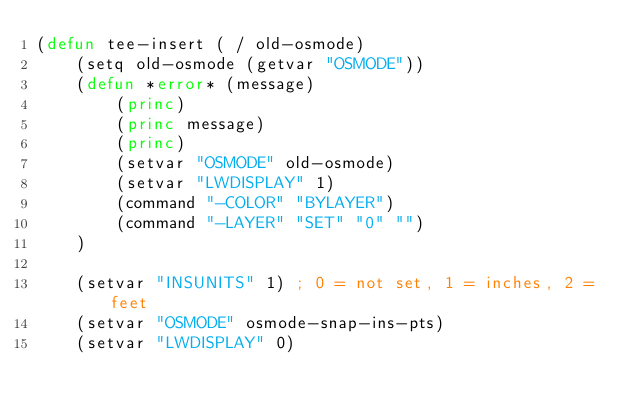Convert code to text. <code><loc_0><loc_0><loc_500><loc_500><_Lisp_>(defun tee-insert ( / old-osmode)
    (setq old-osmode (getvar "OSMODE"))
    (defun *error* (message)
        (princ)
        (princ message)
        (princ)
        (setvar "OSMODE" old-osmode)
        (setvar "LWDISPLAY" 1)
        (command "-COLOR" "BYLAYER")
        (command "-LAYER" "SET" "0" "")
    )
    
    (setvar "INSUNITS" 1) ; 0 = not set, 1 = inches, 2 = feet
    (setvar "OSMODE" osmode-snap-ins-pts)
    (setvar "LWDISPLAY" 0)</code> 